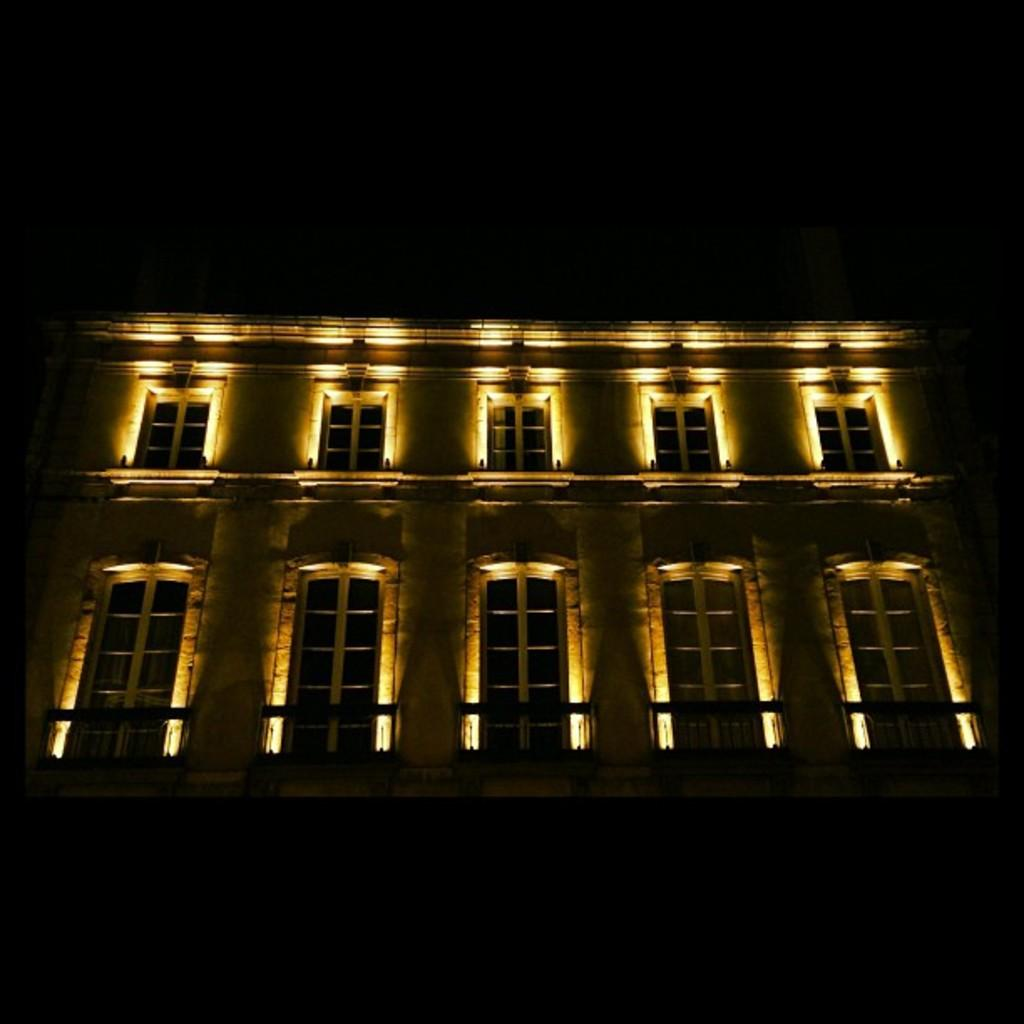What is the main structure visible in the image? There is a building in the image. Are there any specific features of the building that can be observed? Yes, the building has lights at the center. What type of news can be heard coming from the boot in the image? There is no boot present in the image, and therefore no news can be heard coming from it. 